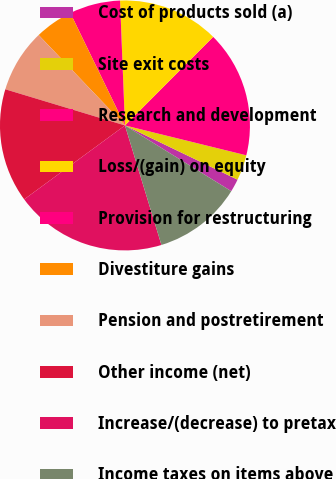<chart> <loc_0><loc_0><loc_500><loc_500><pie_chart><fcel>Cost of products sold (a)<fcel>Site exit costs<fcel>Research and development<fcel>Loss/(gain) on equity<fcel>Provision for restructuring<fcel>Divestiture gains<fcel>Pension and postretirement<fcel>Other income (net)<fcel>Increase/(decrease) to pretax<fcel>Income taxes on items above<nl><fcel>1.67%<fcel>3.3%<fcel>16.37%<fcel>13.1%<fcel>6.57%<fcel>4.93%<fcel>8.2%<fcel>14.74%<fcel>19.64%<fcel>11.47%<nl></chart> 